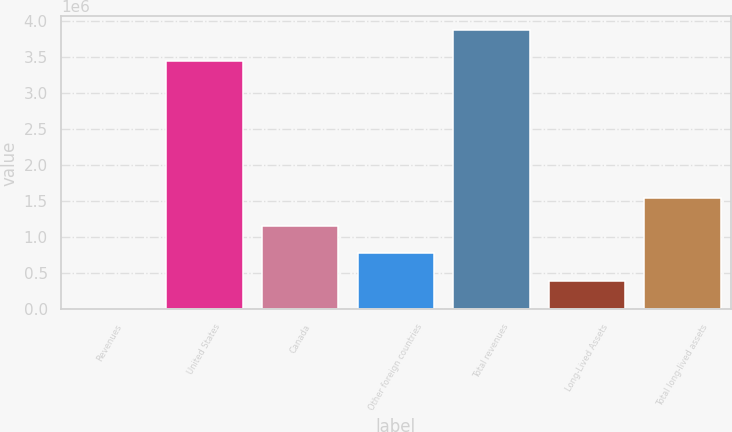Convert chart to OTSL. <chart><loc_0><loc_0><loc_500><loc_500><bar_chart><fcel>Revenues<fcel>United States<fcel>Canada<fcel>Other foreign countries<fcel>Total revenues<fcel>Long-Lived Assets<fcel>Total long-lived assets<nl><fcel>2015<fcel>3.44114e+06<fcel>1.16217e+06<fcel>775449<fcel>3.86919e+06<fcel>388732<fcel>1.54888e+06<nl></chart> 